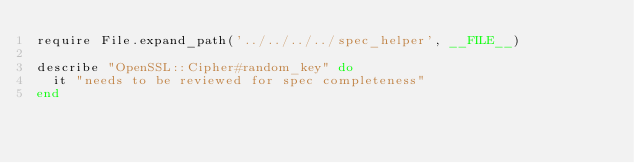<code> <loc_0><loc_0><loc_500><loc_500><_Ruby_>require File.expand_path('../../../../spec_helper', __FILE__)

describe "OpenSSL::Cipher#random_key" do
  it "needs to be reviewed for spec completeness"
end
</code> 